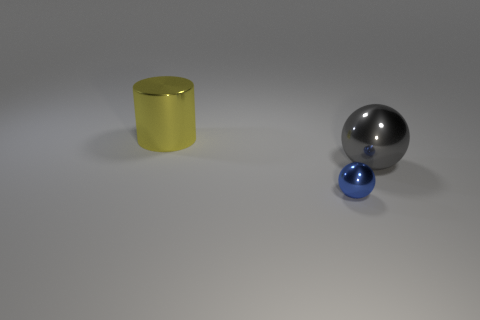Add 2 balls. How many objects exist? 5 Subtract all balls. How many objects are left? 1 Subtract 1 balls. How many balls are left? 1 Add 1 large purple metal objects. How many large purple metal objects exist? 1 Subtract 0 red blocks. How many objects are left? 3 Subtract all tiny cyan metallic objects. Subtract all balls. How many objects are left? 1 Add 1 yellow shiny cylinders. How many yellow shiny cylinders are left? 2 